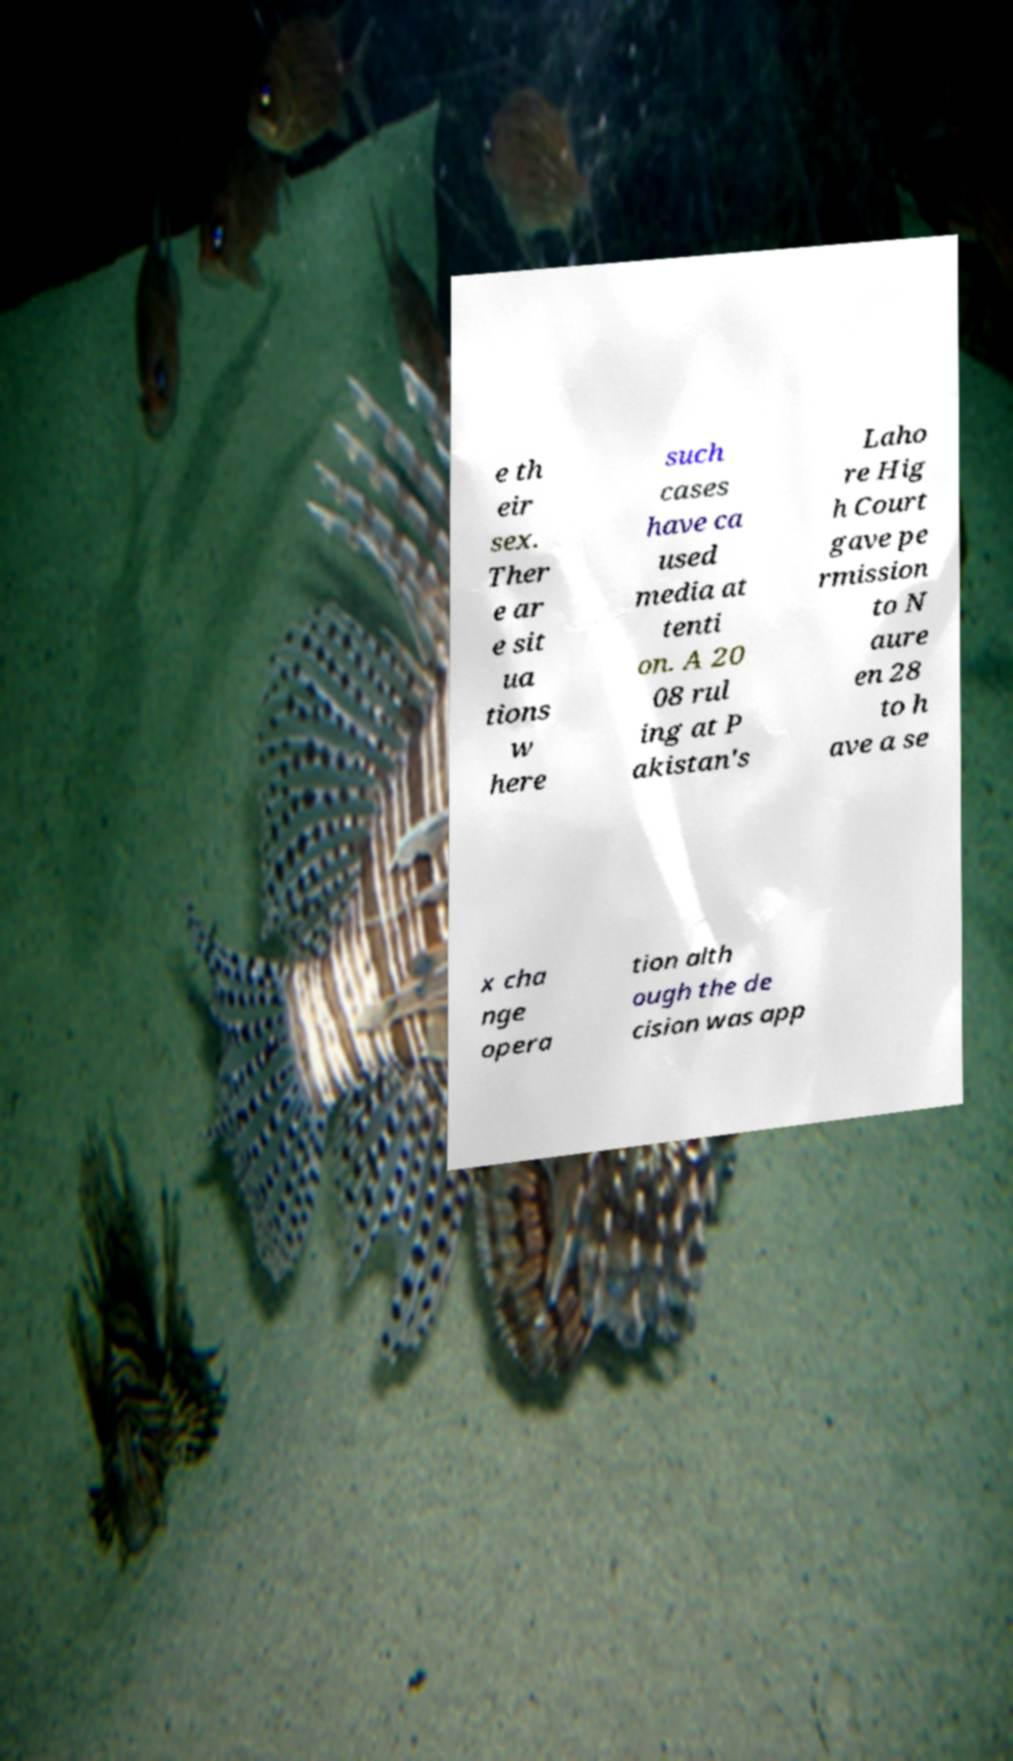Could you extract and type out the text from this image? e th eir sex. Ther e ar e sit ua tions w here such cases have ca used media at tenti on. A 20 08 rul ing at P akistan's Laho re Hig h Court gave pe rmission to N aure en 28 to h ave a se x cha nge opera tion alth ough the de cision was app 